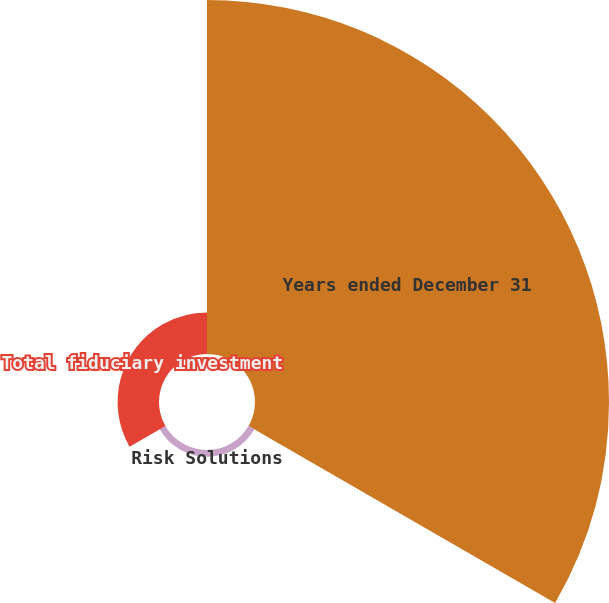Convert chart to OTSL. <chart><loc_0><loc_0><loc_500><loc_500><pie_chart><fcel>Years ended December 31<fcel>Risk Solutions<fcel>Total fiduciary investment<nl><fcel>88.04%<fcel>1.66%<fcel>10.3%<nl></chart> 